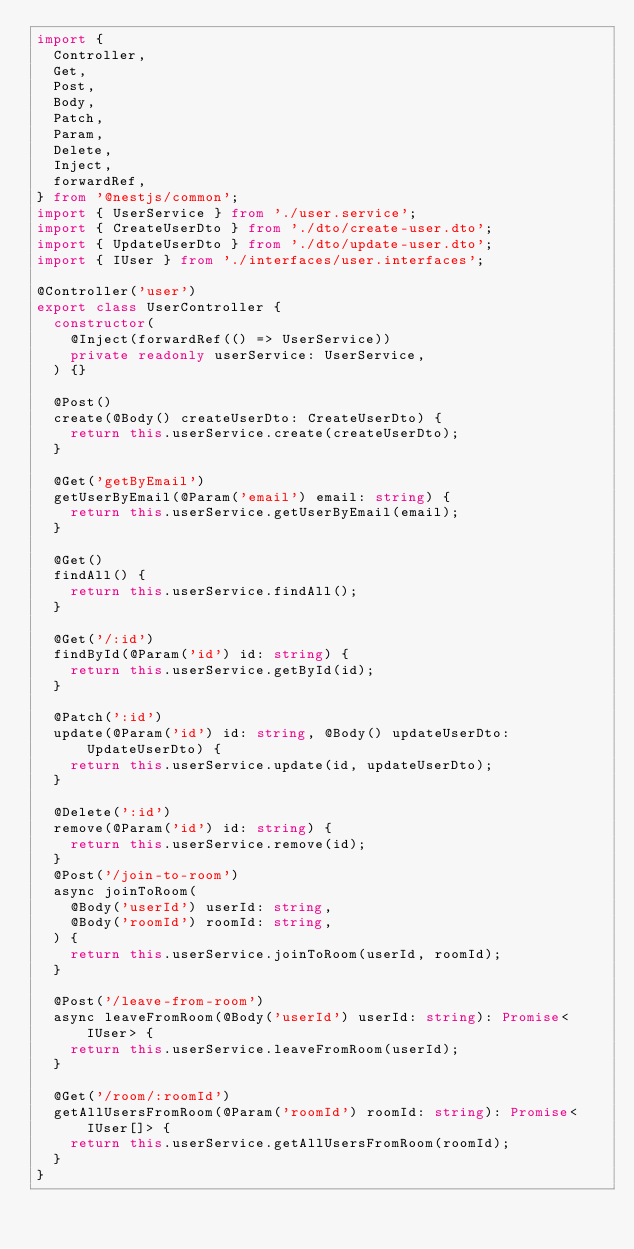Convert code to text. <code><loc_0><loc_0><loc_500><loc_500><_TypeScript_>import {
  Controller,
  Get,
  Post,
  Body,
  Patch,
  Param,
  Delete,
  Inject,
  forwardRef,
} from '@nestjs/common';
import { UserService } from './user.service';
import { CreateUserDto } from './dto/create-user.dto';
import { UpdateUserDto } from './dto/update-user.dto';
import { IUser } from './interfaces/user.interfaces';

@Controller('user')
export class UserController {
  constructor(
    @Inject(forwardRef(() => UserService))
    private readonly userService: UserService,
  ) {}

  @Post()
  create(@Body() createUserDto: CreateUserDto) {
    return this.userService.create(createUserDto);
  }

  @Get('getByEmail')
  getUserByEmail(@Param('email') email: string) {
    return this.userService.getUserByEmail(email);
  }

  @Get()
  findAll() {
    return this.userService.findAll();
  }

  @Get('/:id')
  findById(@Param('id') id: string) {
    return this.userService.getById(id);
  }

  @Patch(':id')
  update(@Param('id') id: string, @Body() updateUserDto: UpdateUserDto) {
    return this.userService.update(id, updateUserDto);
  }

  @Delete(':id')
  remove(@Param('id') id: string) {
    return this.userService.remove(id);
  }
  @Post('/join-to-room')
  async joinToRoom(
    @Body('userId') userId: string,
    @Body('roomId') roomId: string,
  ) {
    return this.userService.joinToRoom(userId, roomId);
  }

  @Post('/leave-from-room')
  async leaveFromRoom(@Body('userId') userId: string): Promise<IUser> {
    return this.userService.leaveFromRoom(userId);
  }

  @Get('/room/:roomId')
  getAllUsersFromRoom(@Param('roomId') roomId: string): Promise<IUser[]> {
    return this.userService.getAllUsersFromRoom(roomId);
  }
}
</code> 